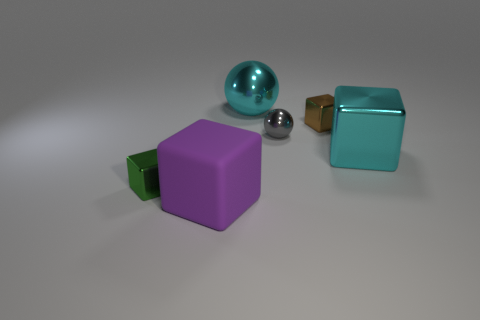Subtract all brown metal cubes. How many cubes are left? 3 Subtract all purple cubes. How many cubes are left? 3 Add 3 purple matte objects. How many objects exist? 9 Subtract all blue cubes. Subtract all green balls. How many cubes are left? 4 Subtract all cubes. How many objects are left? 2 Add 5 shiny blocks. How many shiny blocks exist? 8 Subtract 0 brown spheres. How many objects are left? 6 Subtract all tiny cyan matte blocks. Subtract all rubber cubes. How many objects are left? 5 Add 1 purple matte cubes. How many purple matte cubes are left? 2 